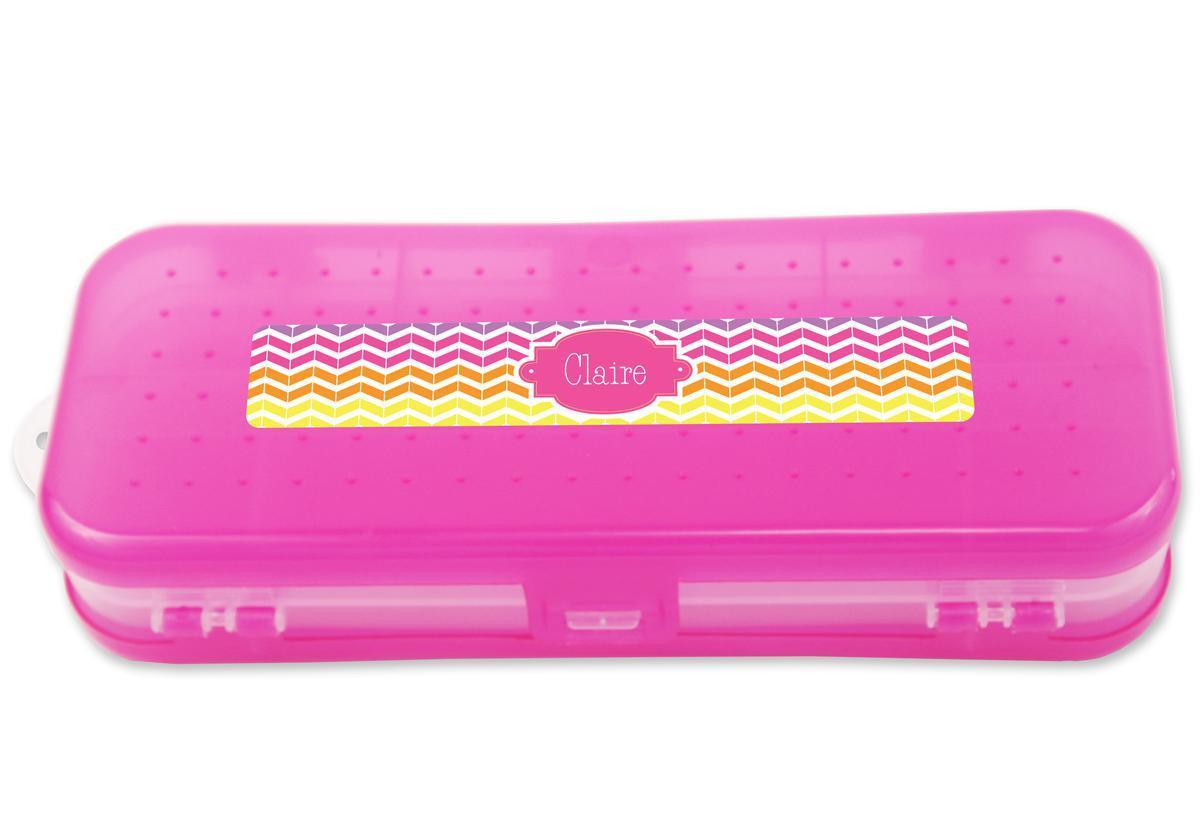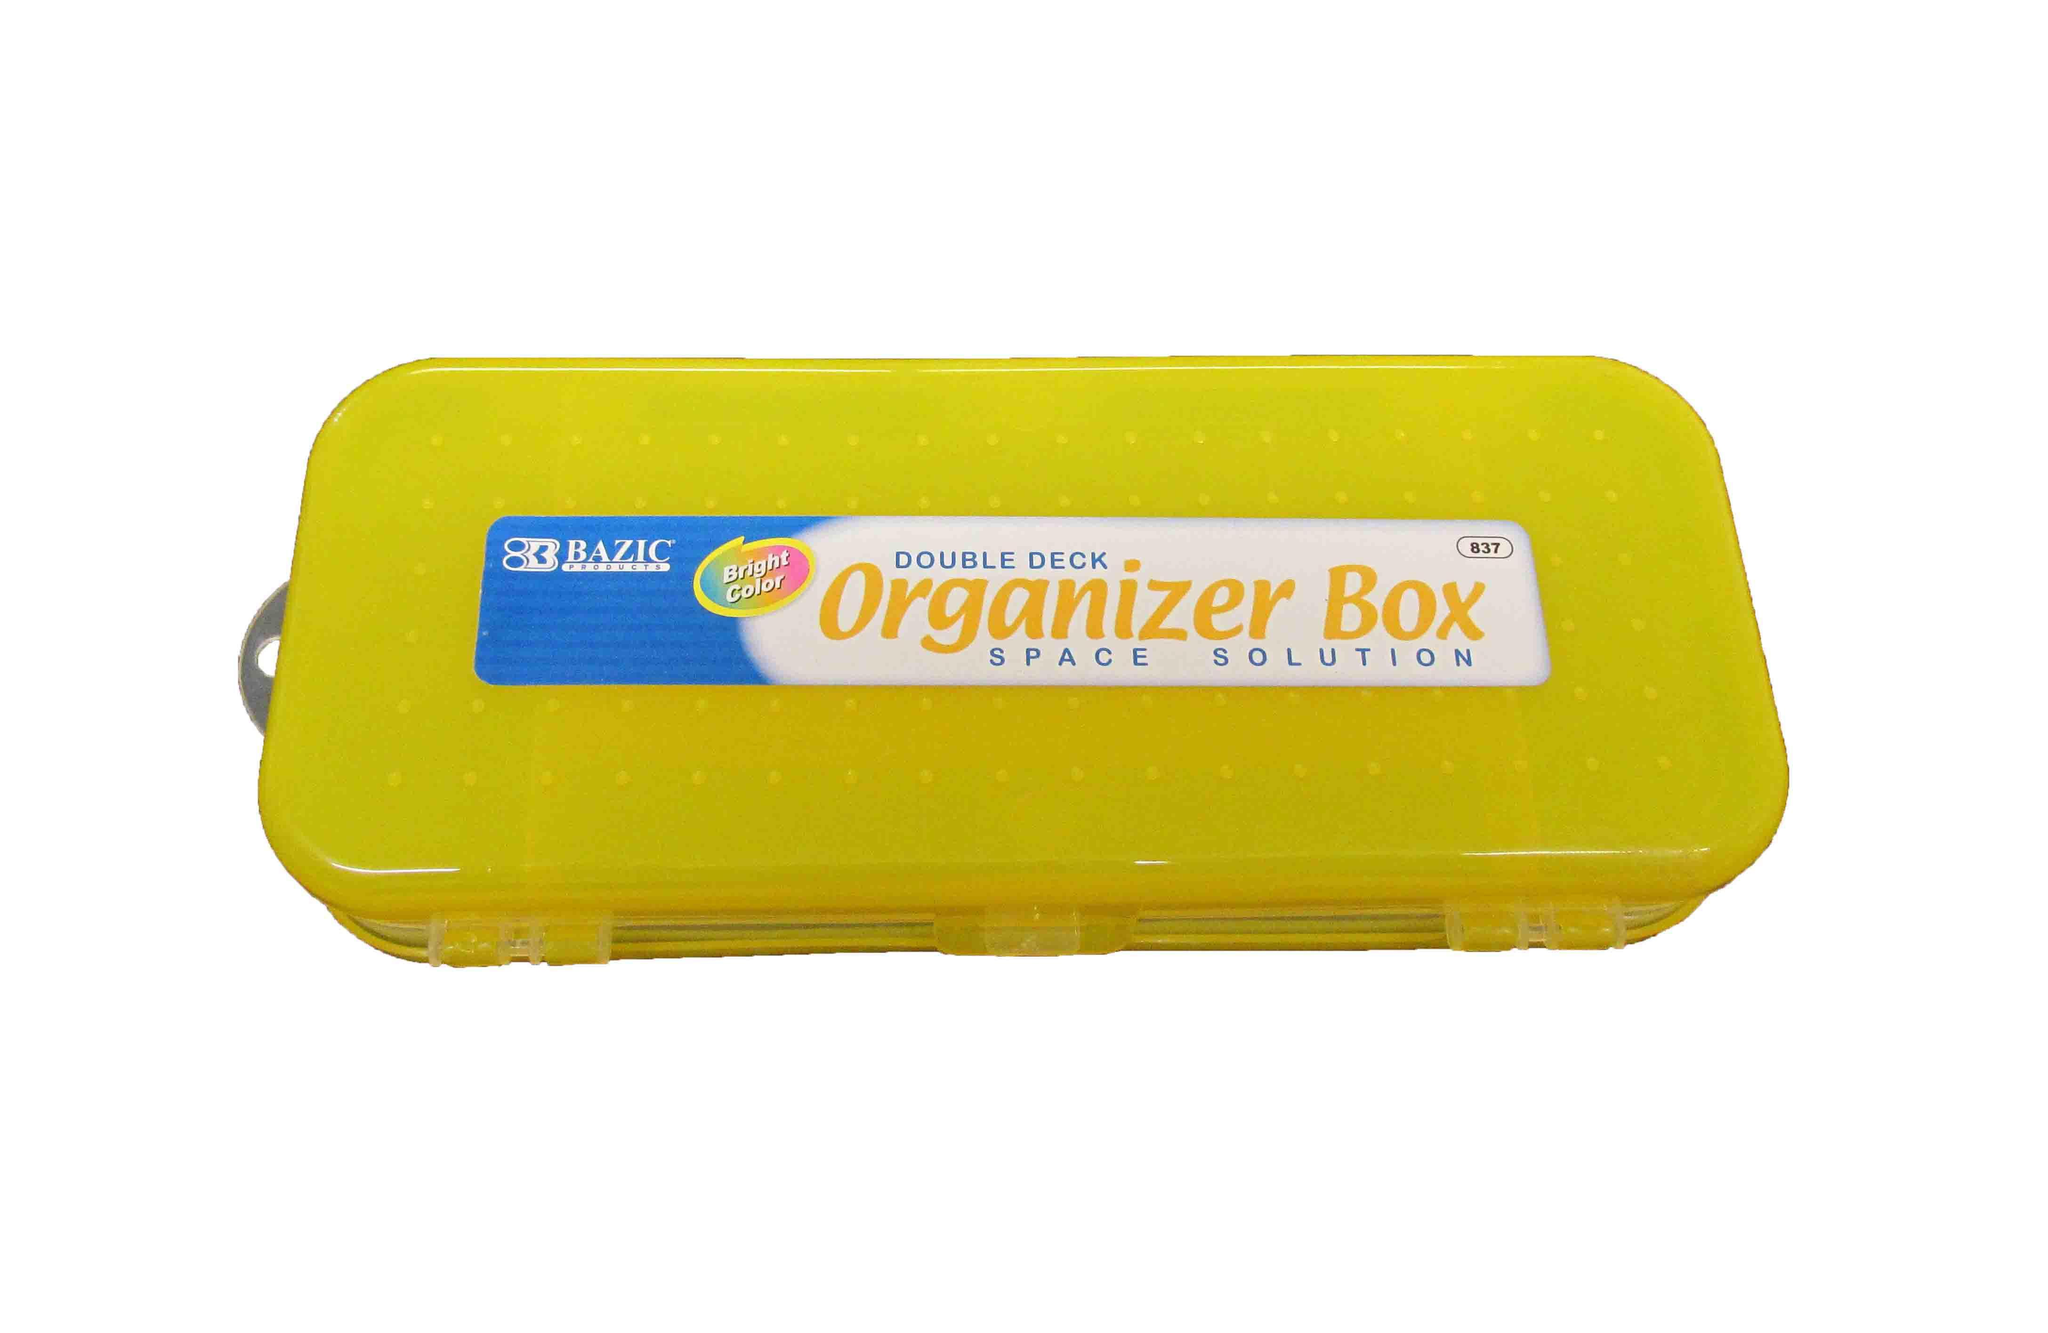The first image is the image on the left, the second image is the image on the right. Assess this claim about the two images: "There is at most two pencil holders.". Correct or not? Answer yes or no. Yes. The first image is the image on the left, the second image is the image on the right. For the images displayed, is the sentence "At least one image shows a pencil case decorated with an animated scene inspired by a kids' movie." factually correct? Answer yes or no. No. 